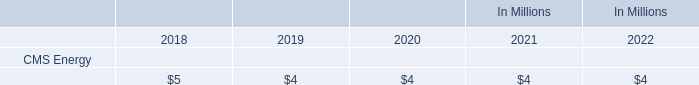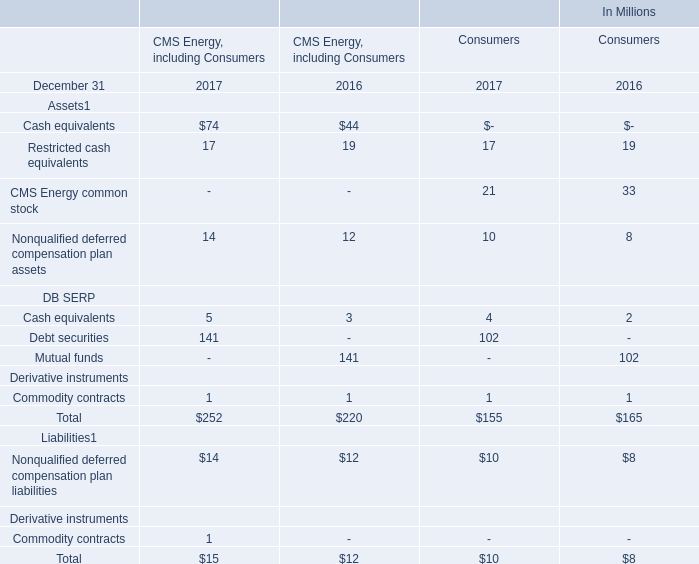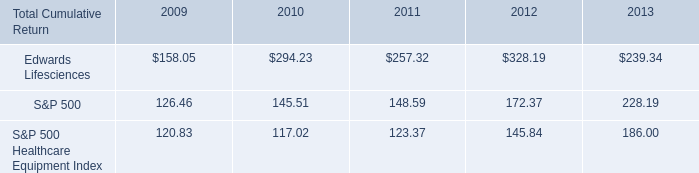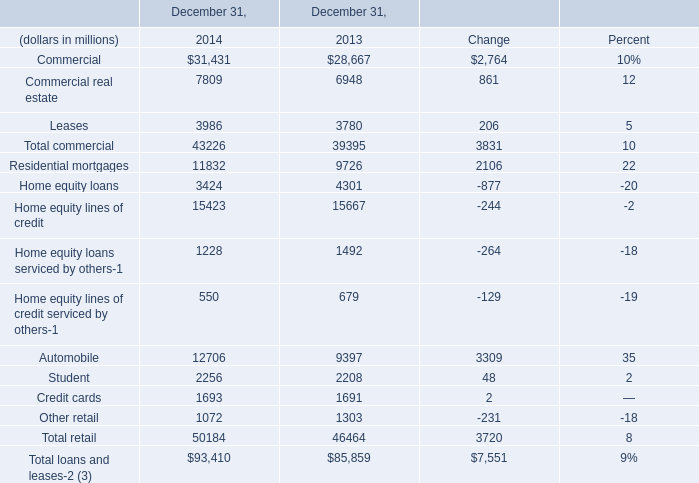what was the cumulative percentage return for five year period ended 2013? 
Computations: ((239.34 - 100) / 100)
Answer: 1.3934. 